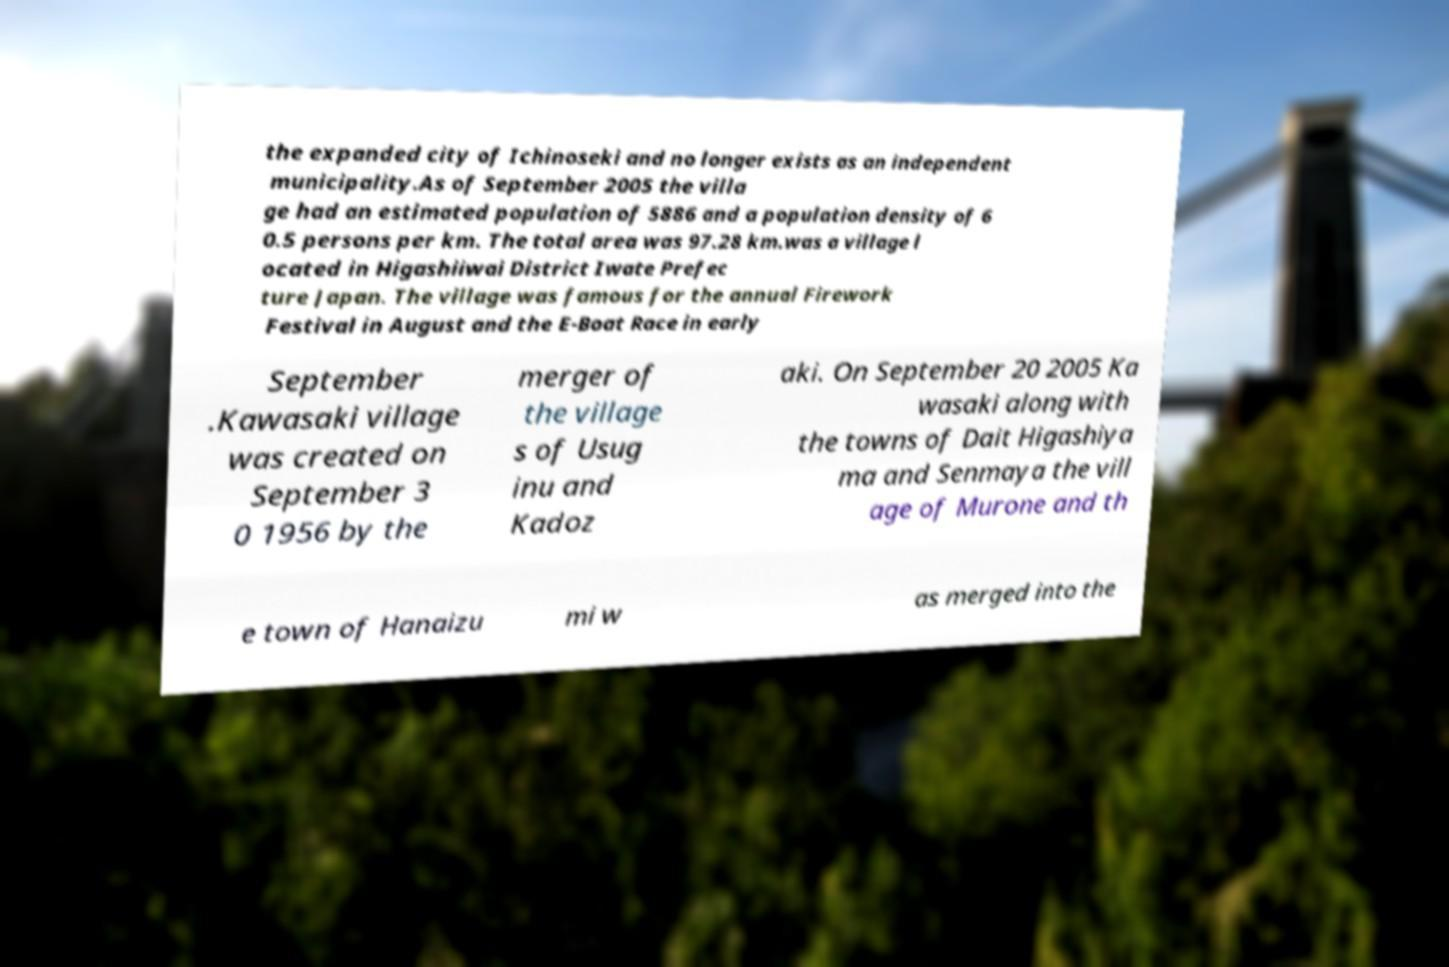For documentation purposes, I need the text within this image transcribed. Could you provide that? the expanded city of Ichinoseki and no longer exists as an independent municipality.As of September 2005 the villa ge had an estimated population of 5886 and a population density of 6 0.5 persons per km. The total area was 97.28 km.was a village l ocated in Higashiiwai District Iwate Prefec ture Japan. The village was famous for the annual Firework Festival in August and the E-Boat Race in early September .Kawasaki village was created on September 3 0 1956 by the merger of the village s of Usug inu and Kadoz aki. On September 20 2005 Ka wasaki along with the towns of Dait Higashiya ma and Senmaya the vill age of Murone and th e town of Hanaizu mi w as merged into the 